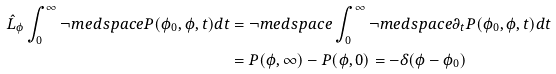Convert formula to latex. <formula><loc_0><loc_0><loc_500><loc_500>\hat { L } _ { \phi } \int _ { 0 } ^ { \infty } \neg m e d s p a c e P ( \phi _ { 0 } , \phi , t ) d t & = \neg m e d s p a c e \int _ { 0 } ^ { \infty } \neg m e d s p a c e \partial _ { t } P ( \phi _ { 0 } , \phi , t ) d t \\ & = P ( \phi , \infty ) - P ( \phi , 0 ) = - \delta ( \phi - \phi _ { 0 } )</formula> 